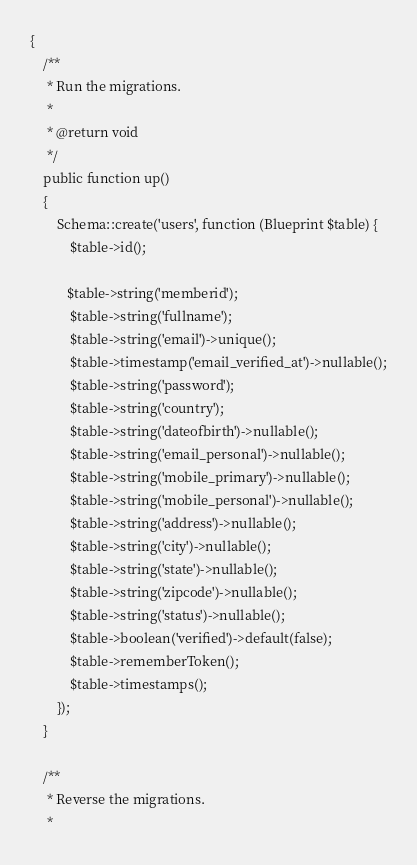<code> <loc_0><loc_0><loc_500><loc_500><_PHP_>{
    /**
     * Run the migrations.
     *
     * @return void
     */
    public function up()
    {
        Schema::create('users', function (Blueprint $table) {
            $table->id();
           
           $table->string('memberid');
            $table->string('fullname');
            $table->string('email')->unique();
            $table->timestamp('email_verified_at')->nullable();
            $table->string('password');
            $table->string('country');
            $table->string('dateofbirth')->nullable();
            $table->string('email_personal')->nullable();
            $table->string('mobile_primary')->nullable();
            $table->string('mobile_personal')->nullable();
            $table->string('address')->nullable();
            $table->string('city')->nullable();
            $table->string('state')->nullable();
            $table->string('zipcode')->nullable();
            $table->string('status')->nullable();
            $table->boolean('verified')->default(false);
            $table->rememberToken();
            $table->timestamps();
        });
    }

    /**
     * Reverse the migrations.
     *</code> 